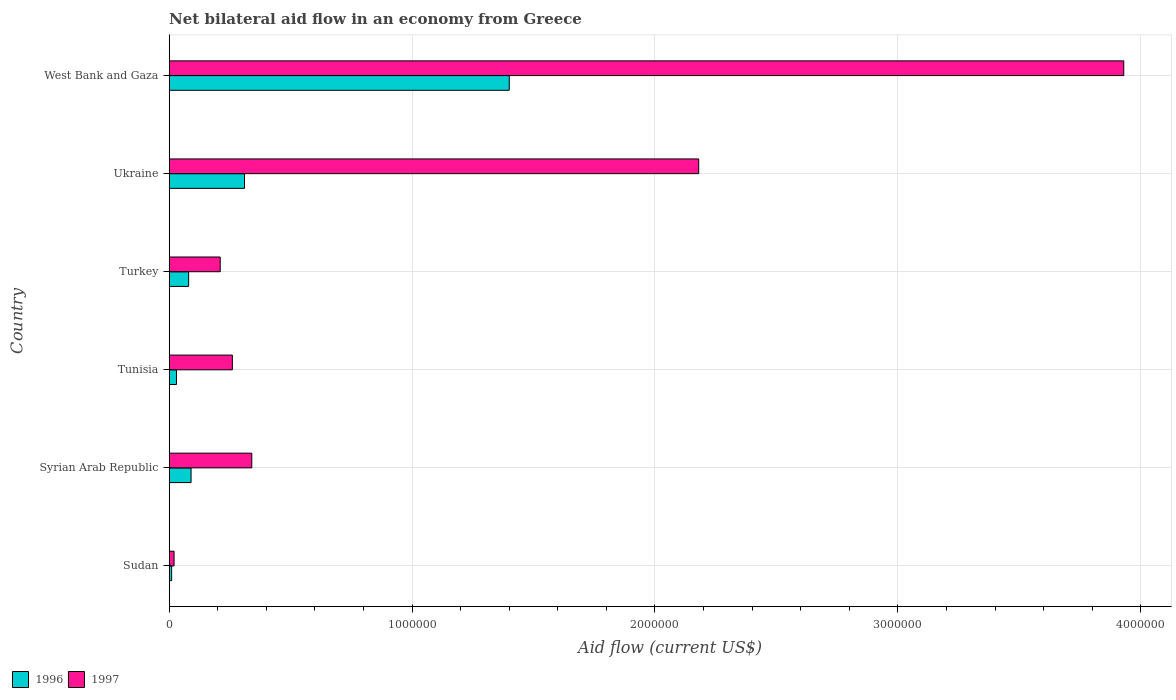How many groups of bars are there?
Provide a succinct answer. 6. Are the number of bars per tick equal to the number of legend labels?
Keep it short and to the point. Yes. How many bars are there on the 4th tick from the bottom?
Ensure brevity in your answer.  2. What is the label of the 6th group of bars from the top?
Your answer should be compact. Sudan. What is the net bilateral aid flow in 1996 in West Bank and Gaza?
Your answer should be very brief. 1.40e+06. Across all countries, what is the maximum net bilateral aid flow in 1997?
Keep it short and to the point. 3.93e+06. Across all countries, what is the minimum net bilateral aid flow in 1996?
Your answer should be compact. 10000. In which country was the net bilateral aid flow in 1996 maximum?
Your response must be concise. West Bank and Gaza. In which country was the net bilateral aid flow in 1997 minimum?
Your answer should be very brief. Sudan. What is the total net bilateral aid flow in 1996 in the graph?
Provide a succinct answer. 1.92e+06. What is the difference between the net bilateral aid flow in 1996 in Tunisia and that in West Bank and Gaza?
Offer a terse response. -1.37e+06. What is the average net bilateral aid flow in 1996 per country?
Keep it short and to the point. 3.20e+05. What is the difference between the net bilateral aid flow in 1996 and net bilateral aid flow in 1997 in Syrian Arab Republic?
Your answer should be very brief. -2.50e+05. What is the ratio of the net bilateral aid flow in 1996 in Tunisia to that in Ukraine?
Your answer should be very brief. 0.1. Is the difference between the net bilateral aid flow in 1996 in Sudan and Turkey greater than the difference between the net bilateral aid flow in 1997 in Sudan and Turkey?
Offer a very short reply. Yes. What is the difference between the highest and the second highest net bilateral aid flow in 1996?
Keep it short and to the point. 1.09e+06. What is the difference between the highest and the lowest net bilateral aid flow in 1996?
Give a very brief answer. 1.39e+06. What is the difference between two consecutive major ticks on the X-axis?
Offer a terse response. 1.00e+06. How many legend labels are there?
Your answer should be very brief. 2. How are the legend labels stacked?
Your answer should be very brief. Horizontal. What is the title of the graph?
Provide a short and direct response. Net bilateral aid flow in an economy from Greece. What is the Aid flow (current US$) in 1996 in Sudan?
Provide a short and direct response. 10000. What is the Aid flow (current US$) in 1997 in Sudan?
Ensure brevity in your answer.  2.00e+04. What is the Aid flow (current US$) of 1996 in Tunisia?
Offer a very short reply. 3.00e+04. What is the Aid flow (current US$) in 1997 in Turkey?
Your response must be concise. 2.10e+05. What is the Aid flow (current US$) in 1996 in Ukraine?
Give a very brief answer. 3.10e+05. What is the Aid flow (current US$) of 1997 in Ukraine?
Your answer should be very brief. 2.18e+06. What is the Aid flow (current US$) in 1996 in West Bank and Gaza?
Your answer should be very brief. 1.40e+06. What is the Aid flow (current US$) of 1997 in West Bank and Gaza?
Your answer should be very brief. 3.93e+06. Across all countries, what is the maximum Aid flow (current US$) of 1996?
Provide a succinct answer. 1.40e+06. Across all countries, what is the maximum Aid flow (current US$) in 1997?
Ensure brevity in your answer.  3.93e+06. What is the total Aid flow (current US$) of 1996 in the graph?
Your answer should be very brief. 1.92e+06. What is the total Aid flow (current US$) of 1997 in the graph?
Your answer should be very brief. 6.94e+06. What is the difference between the Aid flow (current US$) in 1996 in Sudan and that in Syrian Arab Republic?
Offer a very short reply. -8.00e+04. What is the difference between the Aid flow (current US$) of 1997 in Sudan and that in Syrian Arab Republic?
Provide a short and direct response. -3.20e+05. What is the difference between the Aid flow (current US$) of 1997 in Sudan and that in Turkey?
Your answer should be very brief. -1.90e+05. What is the difference between the Aid flow (current US$) in 1996 in Sudan and that in Ukraine?
Give a very brief answer. -3.00e+05. What is the difference between the Aid flow (current US$) of 1997 in Sudan and that in Ukraine?
Give a very brief answer. -2.16e+06. What is the difference between the Aid flow (current US$) in 1996 in Sudan and that in West Bank and Gaza?
Your answer should be very brief. -1.39e+06. What is the difference between the Aid flow (current US$) of 1997 in Sudan and that in West Bank and Gaza?
Provide a short and direct response. -3.91e+06. What is the difference between the Aid flow (current US$) of 1996 in Syrian Arab Republic and that in Tunisia?
Make the answer very short. 6.00e+04. What is the difference between the Aid flow (current US$) in 1997 in Syrian Arab Republic and that in Tunisia?
Your answer should be compact. 8.00e+04. What is the difference between the Aid flow (current US$) of 1996 in Syrian Arab Republic and that in Turkey?
Your response must be concise. 10000. What is the difference between the Aid flow (current US$) in 1997 in Syrian Arab Republic and that in Turkey?
Provide a short and direct response. 1.30e+05. What is the difference between the Aid flow (current US$) in 1997 in Syrian Arab Republic and that in Ukraine?
Your answer should be very brief. -1.84e+06. What is the difference between the Aid flow (current US$) of 1996 in Syrian Arab Republic and that in West Bank and Gaza?
Offer a terse response. -1.31e+06. What is the difference between the Aid flow (current US$) in 1997 in Syrian Arab Republic and that in West Bank and Gaza?
Your answer should be very brief. -3.59e+06. What is the difference between the Aid flow (current US$) in 1997 in Tunisia and that in Turkey?
Provide a short and direct response. 5.00e+04. What is the difference between the Aid flow (current US$) of 1996 in Tunisia and that in Ukraine?
Provide a succinct answer. -2.80e+05. What is the difference between the Aid flow (current US$) of 1997 in Tunisia and that in Ukraine?
Give a very brief answer. -1.92e+06. What is the difference between the Aid flow (current US$) of 1996 in Tunisia and that in West Bank and Gaza?
Offer a very short reply. -1.37e+06. What is the difference between the Aid flow (current US$) in 1997 in Tunisia and that in West Bank and Gaza?
Your response must be concise. -3.67e+06. What is the difference between the Aid flow (current US$) of 1996 in Turkey and that in Ukraine?
Offer a terse response. -2.30e+05. What is the difference between the Aid flow (current US$) in 1997 in Turkey and that in Ukraine?
Make the answer very short. -1.97e+06. What is the difference between the Aid flow (current US$) in 1996 in Turkey and that in West Bank and Gaza?
Ensure brevity in your answer.  -1.32e+06. What is the difference between the Aid flow (current US$) in 1997 in Turkey and that in West Bank and Gaza?
Provide a short and direct response. -3.72e+06. What is the difference between the Aid flow (current US$) in 1996 in Ukraine and that in West Bank and Gaza?
Your answer should be very brief. -1.09e+06. What is the difference between the Aid flow (current US$) of 1997 in Ukraine and that in West Bank and Gaza?
Give a very brief answer. -1.75e+06. What is the difference between the Aid flow (current US$) in 1996 in Sudan and the Aid flow (current US$) in 1997 in Syrian Arab Republic?
Provide a succinct answer. -3.30e+05. What is the difference between the Aid flow (current US$) of 1996 in Sudan and the Aid flow (current US$) of 1997 in Turkey?
Provide a short and direct response. -2.00e+05. What is the difference between the Aid flow (current US$) in 1996 in Sudan and the Aid flow (current US$) in 1997 in Ukraine?
Make the answer very short. -2.17e+06. What is the difference between the Aid flow (current US$) in 1996 in Sudan and the Aid flow (current US$) in 1997 in West Bank and Gaza?
Provide a short and direct response. -3.92e+06. What is the difference between the Aid flow (current US$) of 1996 in Syrian Arab Republic and the Aid flow (current US$) of 1997 in Tunisia?
Provide a short and direct response. -1.70e+05. What is the difference between the Aid flow (current US$) of 1996 in Syrian Arab Republic and the Aid flow (current US$) of 1997 in Turkey?
Your answer should be very brief. -1.20e+05. What is the difference between the Aid flow (current US$) of 1996 in Syrian Arab Republic and the Aid flow (current US$) of 1997 in Ukraine?
Offer a very short reply. -2.09e+06. What is the difference between the Aid flow (current US$) in 1996 in Syrian Arab Republic and the Aid flow (current US$) in 1997 in West Bank and Gaza?
Provide a short and direct response. -3.84e+06. What is the difference between the Aid flow (current US$) in 1996 in Tunisia and the Aid flow (current US$) in 1997 in Turkey?
Keep it short and to the point. -1.80e+05. What is the difference between the Aid flow (current US$) of 1996 in Tunisia and the Aid flow (current US$) of 1997 in Ukraine?
Give a very brief answer. -2.15e+06. What is the difference between the Aid flow (current US$) of 1996 in Tunisia and the Aid flow (current US$) of 1997 in West Bank and Gaza?
Keep it short and to the point. -3.90e+06. What is the difference between the Aid flow (current US$) in 1996 in Turkey and the Aid flow (current US$) in 1997 in Ukraine?
Your answer should be compact. -2.10e+06. What is the difference between the Aid flow (current US$) in 1996 in Turkey and the Aid flow (current US$) in 1997 in West Bank and Gaza?
Your answer should be very brief. -3.85e+06. What is the difference between the Aid flow (current US$) of 1996 in Ukraine and the Aid flow (current US$) of 1997 in West Bank and Gaza?
Your response must be concise. -3.62e+06. What is the average Aid flow (current US$) in 1997 per country?
Offer a very short reply. 1.16e+06. What is the difference between the Aid flow (current US$) in 1996 and Aid flow (current US$) in 1997 in Sudan?
Give a very brief answer. -10000. What is the difference between the Aid flow (current US$) of 1996 and Aid flow (current US$) of 1997 in Syrian Arab Republic?
Make the answer very short. -2.50e+05. What is the difference between the Aid flow (current US$) of 1996 and Aid flow (current US$) of 1997 in Ukraine?
Provide a short and direct response. -1.87e+06. What is the difference between the Aid flow (current US$) in 1996 and Aid flow (current US$) in 1997 in West Bank and Gaza?
Offer a very short reply. -2.53e+06. What is the ratio of the Aid flow (current US$) of 1997 in Sudan to that in Syrian Arab Republic?
Your answer should be very brief. 0.06. What is the ratio of the Aid flow (current US$) in 1996 in Sudan to that in Tunisia?
Ensure brevity in your answer.  0.33. What is the ratio of the Aid flow (current US$) of 1997 in Sudan to that in Tunisia?
Keep it short and to the point. 0.08. What is the ratio of the Aid flow (current US$) of 1996 in Sudan to that in Turkey?
Ensure brevity in your answer.  0.12. What is the ratio of the Aid flow (current US$) in 1997 in Sudan to that in Turkey?
Offer a very short reply. 0.1. What is the ratio of the Aid flow (current US$) of 1996 in Sudan to that in Ukraine?
Your response must be concise. 0.03. What is the ratio of the Aid flow (current US$) in 1997 in Sudan to that in Ukraine?
Your answer should be very brief. 0.01. What is the ratio of the Aid flow (current US$) of 1996 in Sudan to that in West Bank and Gaza?
Make the answer very short. 0.01. What is the ratio of the Aid flow (current US$) of 1997 in Sudan to that in West Bank and Gaza?
Provide a short and direct response. 0.01. What is the ratio of the Aid flow (current US$) in 1996 in Syrian Arab Republic to that in Tunisia?
Give a very brief answer. 3. What is the ratio of the Aid flow (current US$) of 1997 in Syrian Arab Republic to that in Tunisia?
Make the answer very short. 1.31. What is the ratio of the Aid flow (current US$) of 1996 in Syrian Arab Republic to that in Turkey?
Keep it short and to the point. 1.12. What is the ratio of the Aid flow (current US$) in 1997 in Syrian Arab Republic to that in Turkey?
Ensure brevity in your answer.  1.62. What is the ratio of the Aid flow (current US$) in 1996 in Syrian Arab Republic to that in Ukraine?
Offer a terse response. 0.29. What is the ratio of the Aid flow (current US$) of 1997 in Syrian Arab Republic to that in Ukraine?
Offer a very short reply. 0.16. What is the ratio of the Aid flow (current US$) in 1996 in Syrian Arab Republic to that in West Bank and Gaza?
Provide a succinct answer. 0.06. What is the ratio of the Aid flow (current US$) of 1997 in Syrian Arab Republic to that in West Bank and Gaza?
Your answer should be compact. 0.09. What is the ratio of the Aid flow (current US$) in 1996 in Tunisia to that in Turkey?
Offer a very short reply. 0.38. What is the ratio of the Aid flow (current US$) in 1997 in Tunisia to that in Turkey?
Your answer should be very brief. 1.24. What is the ratio of the Aid flow (current US$) of 1996 in Tunisia to that in Ukraine?
Give a very brief answer. 0.1. What is the ratio of the Aid flow (current US$) in 1997 in Tunisia to that in Ukraine?
Your answer should be very brief. 0.12. What is the ratio of the Aid flow (current US$) in 1996 in Tunisia to that in West Bank and Gaza?
Your response must be concise. 0.02. What is the ratio of the Aid flow (current US$) in 1997 in Tunisia to that in West Bank and Gaza?
Keep it short and to the point. 0.07. What is the ratio of the Aid flow (current US$) in 1996 in Turkey to that in Ukraine?
Give a very brief answer. 0.26. What is the ratio of the Aid flow (current US$) of 1997 in Turkey to that in Ukraine?
Offer a terse response. 0.1. What is the ratio of the Aid flow (current US$) in 1996 in Turkey to that in West Bank and Gaza?
Your response must be concise. 0.06. What is the ratio of the Aid flow (current US$) of 1997 in Turkey to that in West Bank and Gaza?
Keep it short and to the point. 0.05. What is the ratio of the Aid flow (current US$) in 1996 in Ukraine to that in West Bank and Gaza?
Keep it short and to the point. 0.22. What is the ratio of the Aid flow (current US$) in 1997 in Ukraine to that in West Bank and Gaza?
Your answer should be very brief. 0.55. What is the difference between the highest and the second highest Aid flow (current US$) of 1996?
Your answer should be very brief. 1.09e+06. What is the difference between the highest and the second highest Aid flow (current US$) in 1997?
Offer a terse response. 1.75e+06. What is the difference between the highest and the lowest Aid flow (current US$) of 1996?
Make the answer very short. 1.39e+06. What is the difference between the highest and the lowest Aid flow (current US$) in 1997?
Make the answer very short. 3.91e+06. 